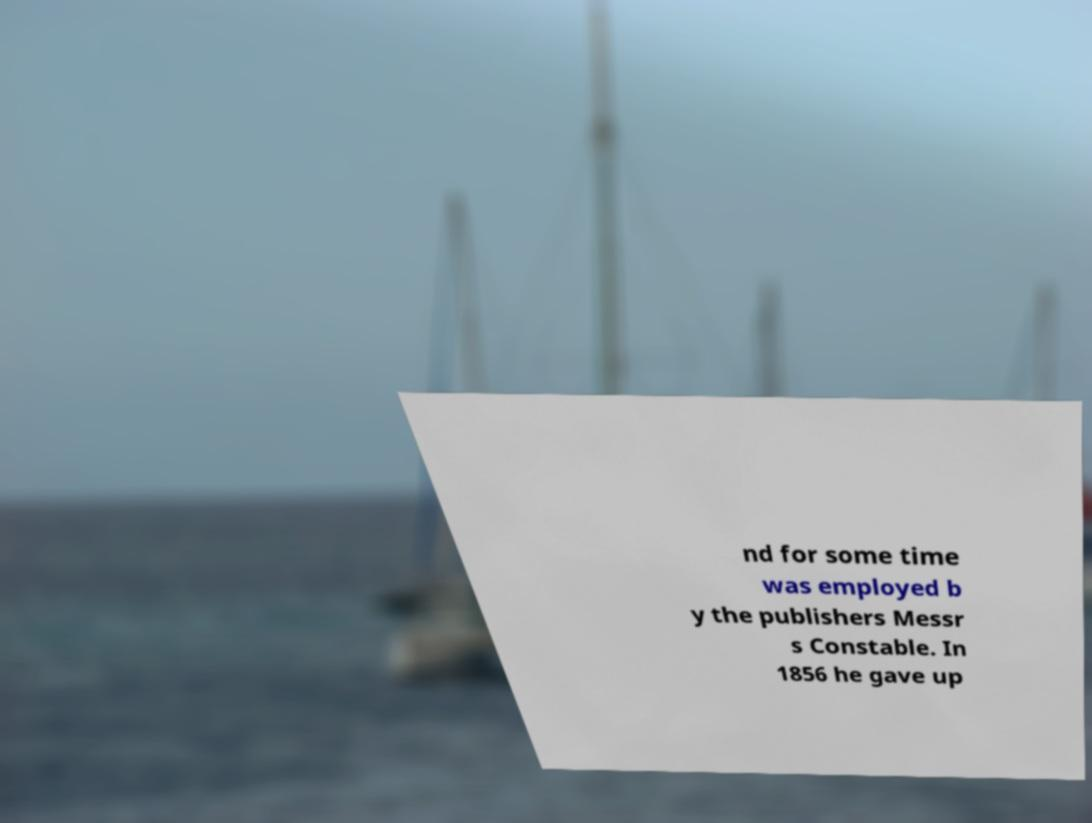Can you accurately transcribe the text from the provided image for me? nd for some time was employed b y the publishers Messr s Constable. In 1856 he gave up 